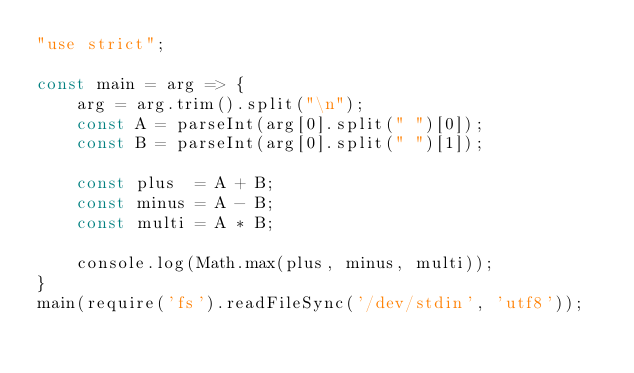Convert code to text. <code><loc_0><loc_0><loc_500><loc_500><_JavaScript_>"use strict";
    
const main = arg => {
    arg = arg.trim().split("\n");
    const A = parseInt(arg[0].split(" ")[0]);
    const B = parseInt(arg[0].split(" ")[1]);
    
    const plus  = A + B;
    const minus = A - B;
    const multi = A * B;
    
    console.log(Math.max(plus, minus, multi));
}
main(require('fs').readFileSync('/dev/stdin', 'utf8'));</code> 